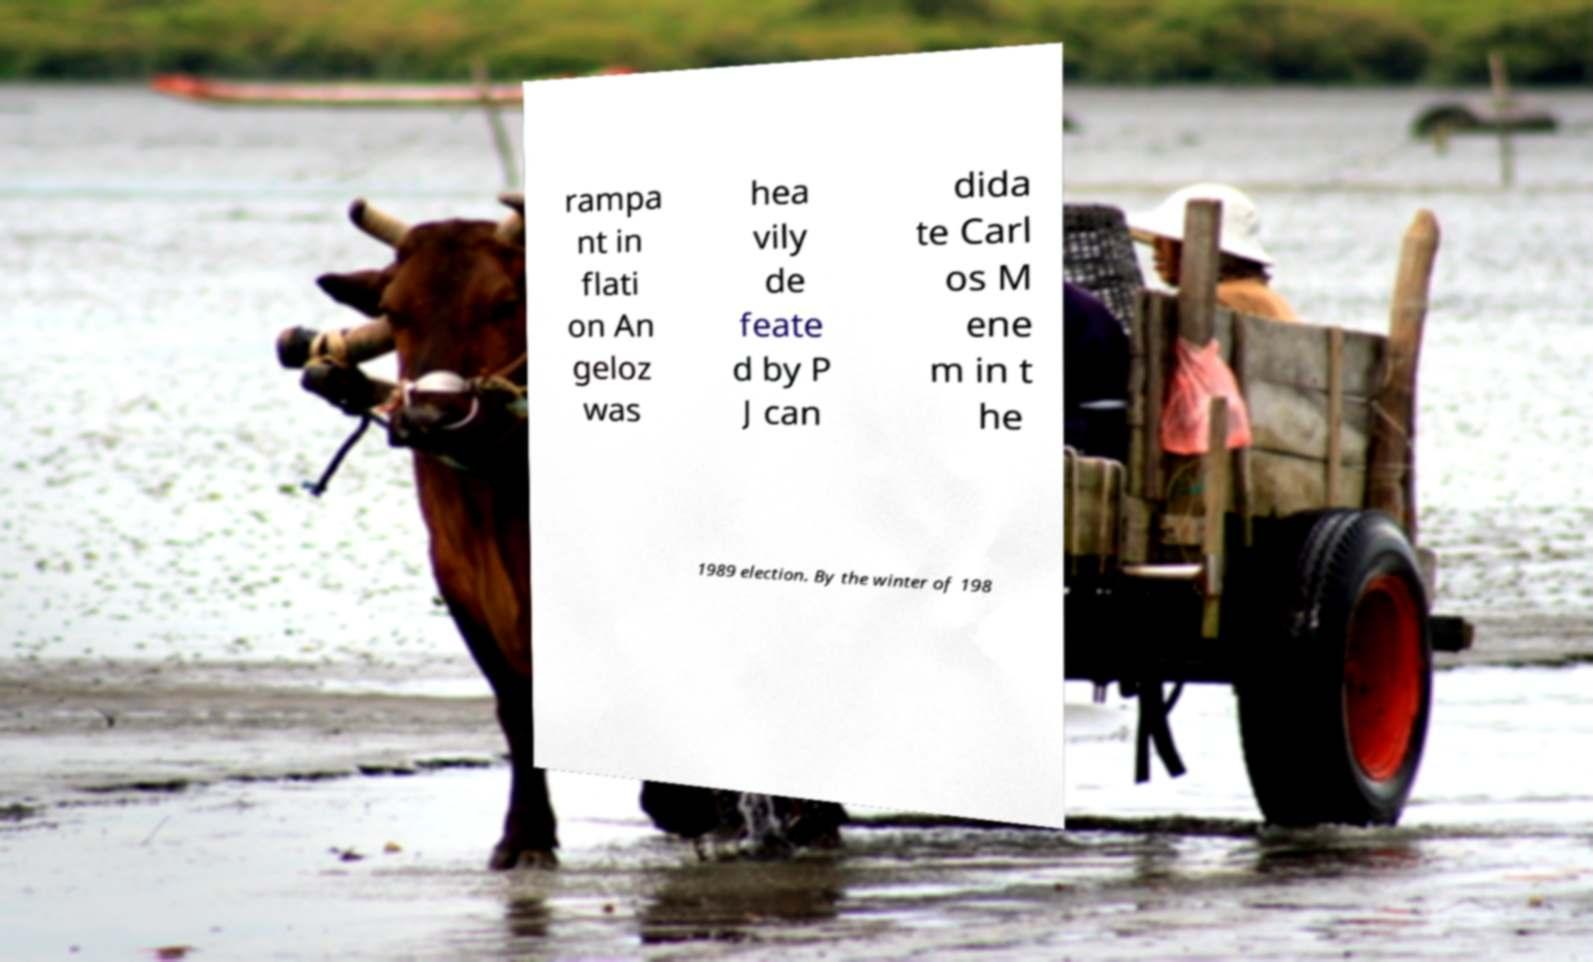I need the written content from this picture converted into text. Can you do that? rampa nt in flati on An geloz was hea vily de feate d by P J can dida te Carl os M ene m in t he 1989 election. By the winter of 198 